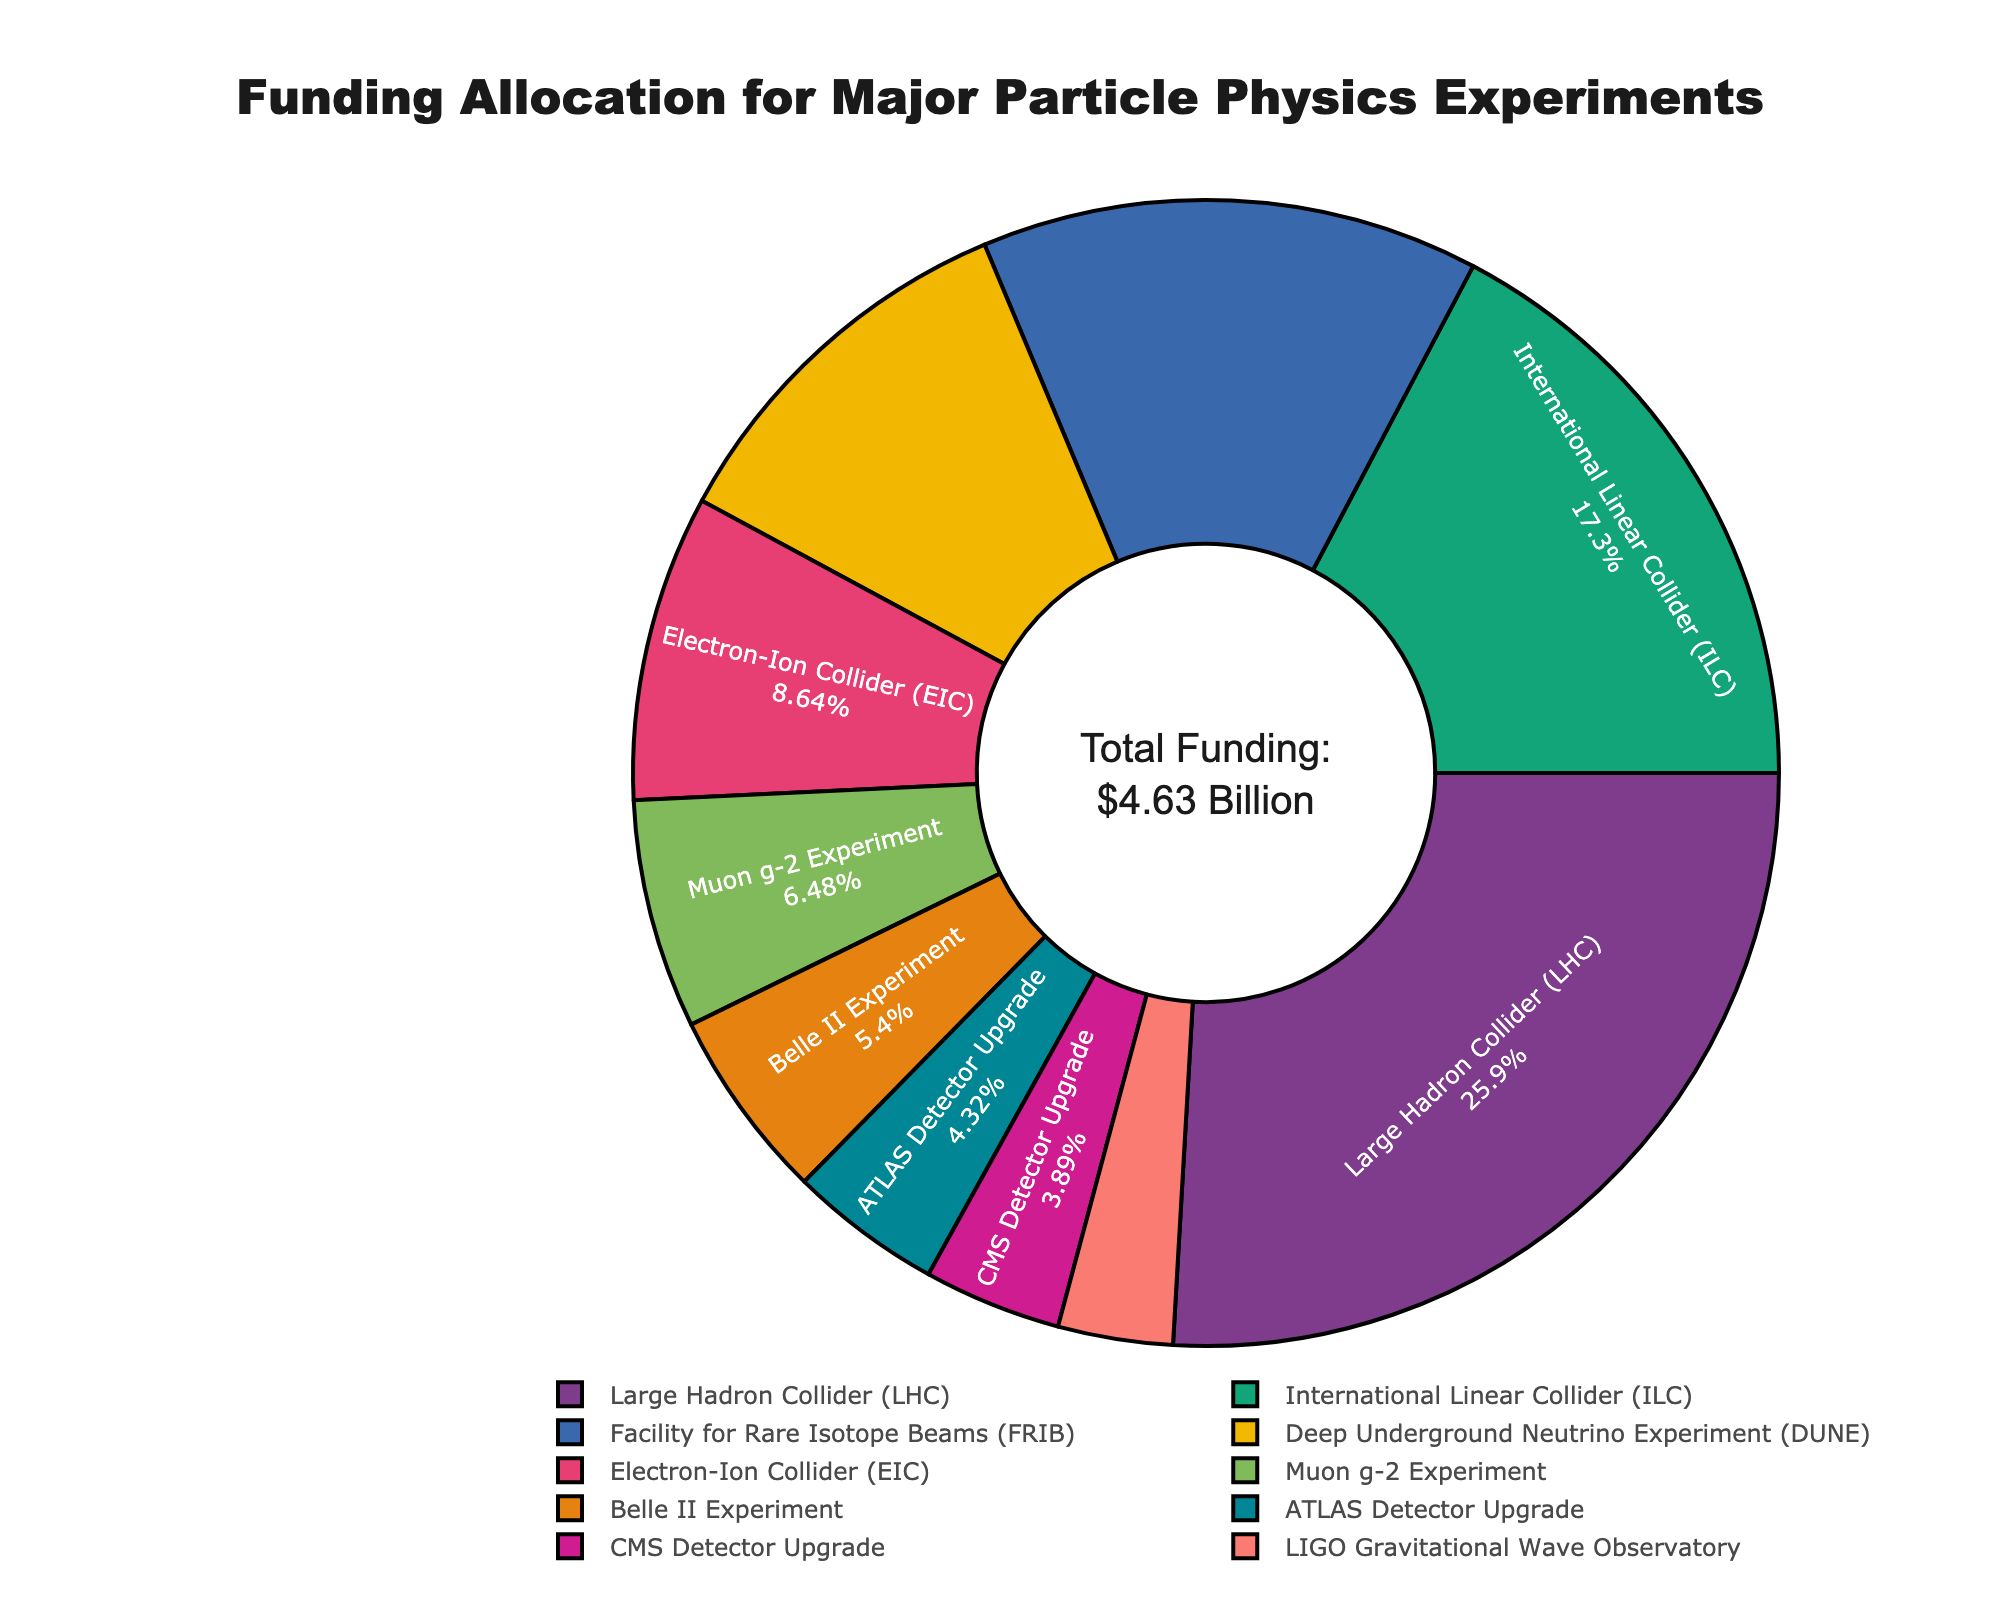What percentage of the total funding is allocated to the Large Hadron Collider (LHC)? The pie chart shows the percentage for each experiment. Locate the segment for LHC and read the percentage value directly.
Answer: 25.92% Which experiment received the least funding? Find the segment with the smallest percentage and read the label corresponding to it.
Answer: LIGO Gravitational Wave Observatory How much more funding did the Facility for Rare Isotope Beams (FRIB) receive compared to the Belle II Experiment? Find the funding amounts for FRIB (650 million USD) and Belle II (250 million USD). Subtract the smaller value from the larger value.
Answer: 400 million USD What is the combined funding for the ATLAS and CMS Detector Upgrades? Identify the funding amounts for ATLAS Detector Upgrade (200 million USD) and CMS Detector Upgrade (180 million USD). Add them together.
Answer: 380 million USD Which experiment has a larger funding allocation, the International Linear Collider (ILC) or the Electron-Ion Collider (EIC)? Compare the funding amounts for ILC (800 million USD) and EIC (400 million USD).
Answer: International Linear Collider (ILC) What percentage of the total funding is allocated to the Deep Underground Neutrino Experiment (DUNE)? Find the segment for DUNE and read the percentage value directly from the pie chart.
Answer: 10.80% Which two experiments together account for the highest percentage of total funding? Identify the two largest segments in the pie chart. Summarize and verify their combined percentage.
Answer: Large Hadron Collider (LHC) and International Linear Collider (ILC) How many experiments received less than 10% each of the total funding? Count the segments in the pie chart with percentages less than 10%.
Answer: 6 What is the total funding for all experiments excluding the LHC? Subtract the funding for LHC (1200 million USD) from the total funding (4630 million USD).
Answer: 3430 million USD Which has more funding: the sum of DUNE and the EIC or the sum of Muon g-2 Experiment and Belle II Experiment? Calculate the sum of funding for DUNE (500 million USD) and EIC (400 million USD), then for Muon g-2 (300 million USD) and Belle II (250 million USD). Compare the two sums.
Answer: DUNE and EIC (900 million USD) 